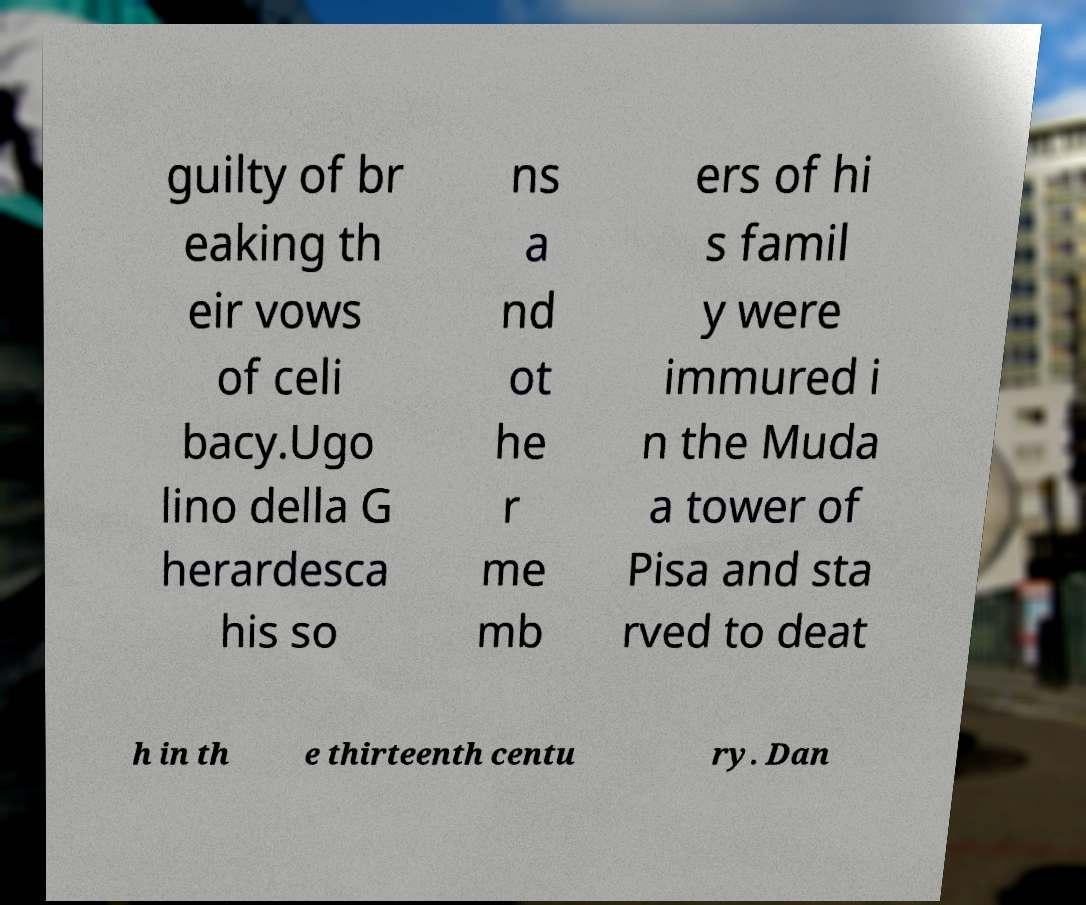What messages or text are displayed in this image? I need them in a readable, typed format. guilty of br eaking th eir vows of celi bacy.Ugo lino della G herardesca his so ns a nd ot he r me mb ers of hi s famil y were immured i n the Muda a tower of Pisa and sta rved to deat h in th e thirteenth centu ry. Dan 